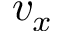Convert formula to latex. <formula><loc_0><loc_0><loc_500><loc_500>v _ { x }</formula> 